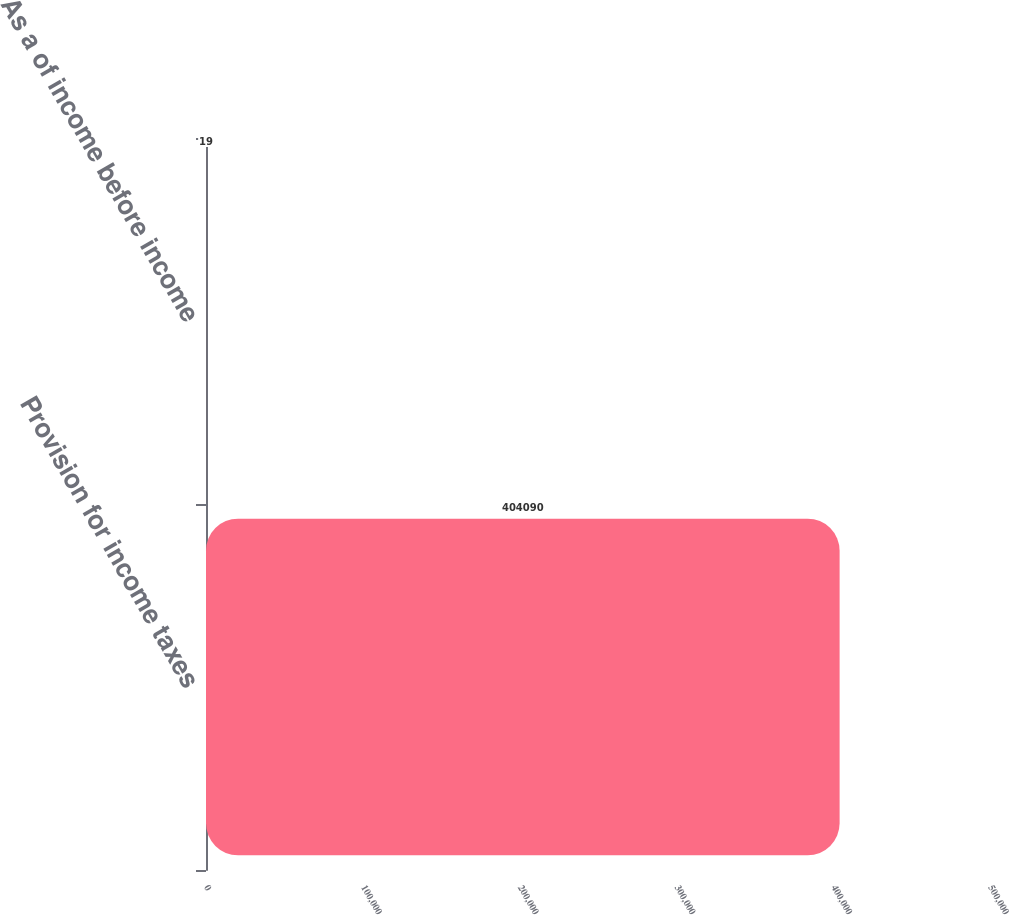<chart> <loc_0><loc_0><loc_500><loc_500><bar_chart><fcel>Provision for income taxes<fcel>As a of income before income<nl><fcel>404090<fcel>19<nl></chart> 